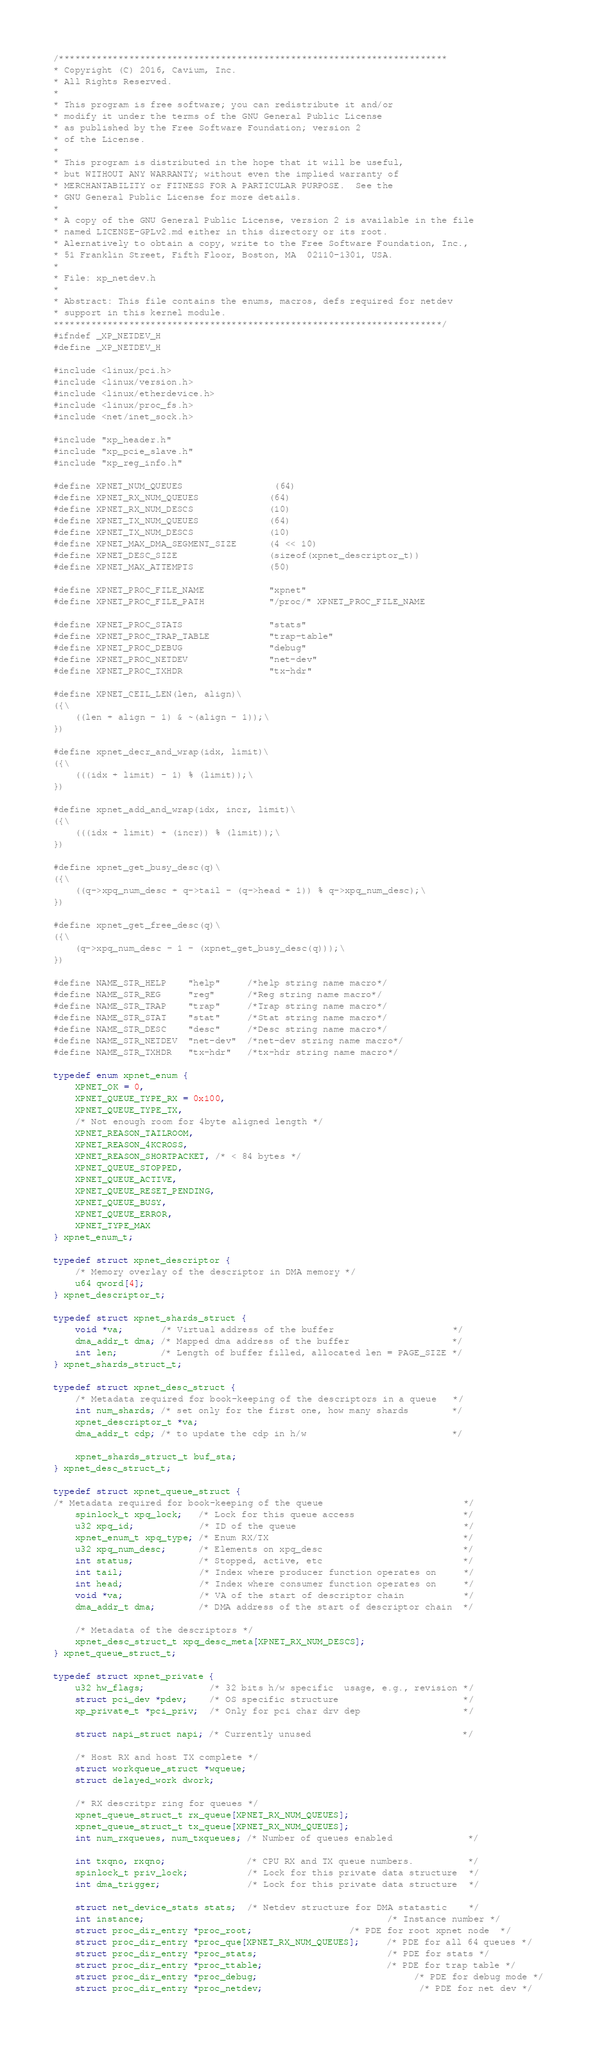Convert code to text. <code><loc_0><loc_0><loc_500><loc_500><_C_>/************************************************************************
* Copyright (C) 2016, Cavium, Inc.
* All Rights Reserved.
*
* This program is free software; you can redistribute it and/or
* modify it under the terms of the GNU General Public License
* as published by the Free Software Foundation; version 2
* of the License.
* 
* This program is distributed in the hope that it will be useful,
* but WITHOUT ANY WARRANTY; without even the implied warranty of
* MERCHANTABILITY or FITNESS FOR A PARTICULAR PURPOSE.  See the
* GNU General Public License for more details.
* 
* A copy of the GNU General Public License, version 2 is available in the file 
* named LICENSE-GPLv2.md either in this directory or its root. 
* Alernatively to obtain a copy, write to the Free Software Foundation, Inc., 
* 51 Franklin Street, Fifth Floor, Boston, MA  02110-1301, USA.
*
* File: xp_netdev.h
* 
* Abstract: This file contains the enums, macros, defs required for netdev 
* support in this kernel module.
************************************************************************/
#ifndef _XP_NETDEV_H
#define _XP_NETDEV_H

#include <linux/pci.h>
#include <linux/version.h>
#include <linux/etherdevice.h>
#include <linux/proc_fs.h>
#include <net/inet_sock.h>

#include "xp_header.h"
#include "xp_pcie_slave.h"
#include "xp_reg_info.h"

#define XPNET_NUM_QUEUES             	(64)
#define XPNET_RX_NUM_QUEUES             (64)
#define XPNET_RX_NUM_DESCS              (10)
#define XPNET_TX_NUM_QUEUES             (64)
#define XPNET_TX_NUM_DESCS              (10)
#define XPNET_MAX_DMA_SEGMENT_SIZE      (4 << 10)
#define XPNET_DESC_SIZE                 (sizeof(xpnet_descriptor_t))
#define XPNET_MAX_ATTEMPTS              (50)

#define XPNET_PROC_FILE_NAME            "xpnet"
#define XPNET_PROC_FILE_PATH            "/proc/" XPNET_PROC_FILE_NAME

#define XPNET_PROC_STATS                "stats"
#define XPNET_PROC_TRAP_TABLE           "trap-table"
#define XPNET_PROC_DEBUG                "debug"
#define XPNET_PROC_NETDEV               "net-dev"
#define XPNET_PROC_TXHDR                "tx-hdr"

#define XPNET_CEIL_LEN(len, align)\
({\
    ((len + align - 1) & ~(align - 1));\
})

#define xpnet_decr_and_wrap(idx, limit)\
({\
    (((idx + limit) - 1) % (limit));\
})

#define xpnet_add_and_wrap(idx, incr, limit)\
({\
    (((idx + limit) + (incr)) % (limit));\
})

#define xpnet_get_busy_desc(q)\
({\
    ((q->xpq_num_desc + q->tail - (q->head + 1)) % q->xpq_num_desc);\
})

#define xpnet_get_free_desc(q)\
({\
    (q->xpq_num_desc - 1 - (xpnet_get_busy_desc(q)));\
})

#define NAME_STR_HELP    "help"     /*help string name macro*/
#define NAME_STR_REG     "reg"      /*Reg string name macro*/
#define NAME_STR_TRAP    "trap"     /*Trap string name macro*/
#define NAME_STR_STAT    "stat"     /*Stat string name macro*/
#define NAME_STR_DESC    "desc"     /*Desc string name macro*/
#define NAME_STR_NETDEV  "net-dev"  /*net-dev string name macro*/
#define NAME_STR_TXHDR   "tx-hdr"   /*tx-hdr string name macro*/

typedef enum xpnet_enum {
    XPNET_OK = 0,
    XPNET_QUEUE_TYPE_RX = 0x100,
    XPNET_QUEUE_TYPE_TX,
    /* Not enough room for 4byte aligned length */
    XPNET_REASON_TAILROOM,
    XPNET_REASON_4KCROSS,
    XPNET_REASON_SHORTPACKET, /* < 84 bytes */
    XPNET_QUEUE_STOPPED,
    XPNET_QUEUE_ACTIVE,
    XPNET_QUEUE_RESET_PENDING,
    XPNET_QUEUE_BUSY,
    XPNET_QUEUE_ERROR,
    XPNET_TYPE_MAX
} xpnet_enum_t;

typedef struct xpnet_descriptor {
    /* Memory overlay of the descriptor in DMA memory */
    u64 qword[4];
} xpnet_descriptor_t;

typedef struct xpnet_shards_struct {
    void *va;       /* Virtual address of the buffer                      */
    dma_addr_t dma; /* Mapped dma address of the buffer                   */
    int len;        /* Length of buffer filled, allocated len = PAGE_SIZE */
} xpnet_shards_struct_t;

typedef struct xpnet_desc_struct {
    /* Metadata required for book-keeping of the descriptors in a queue   */
    int num_shards; /* set only for the first one, how many shards        */
    xpnet_descriptor_t *va;
    dma_addr_t cdp; /* to update the cdp in h/w                           */

    xpnet_shards_struct_t buf_sta;
} xpnet_desc_struct_t;

typedef struct xpnet_queue_struct {
/* Metadata required for book-keeping of the queue                          */
    spinlock_t xpq_lock;   /* Lock for this queue access                    */
    u32 xpq_id;            /* ID of the queue                               */
    xpnet_enum_t xpq_type; /* Enum RX/TX                                    */
    u32 xpq_num_desc;      /* Elements on xpq_desc                          */
    int status;            /* Stopped, active, etc                          */
    int tail;              /* Index where producer function operates on     */
    int head;              /* Index where consumer function operates on     */
    void *va;              /* VA of the start of descriptor chain           */
    dma_addr_t dma;        /* DMA address of the start of descriptor chain  */

    /* Metadata of the descriptors */
    xpnet_desc_struct_t xpq_desc_meta[XPNET_RX_NUM_DESCS];
} xpnet_queue_struct_t;

typedef struct xpnet_private {
    u32 hw_flags;            /* 32 bits h/w specific  usage, e.g., revision */
    struct pci_dev *pdev;    /* OS specific structure                       */
    xp_private_t *pci_priv;  /* Only for pci char drv dep                   */

    struct napi_struct napi; /* Currently unused                            */

    /* Host RX and host TX complete */
    struct workqueue_struct *wqueue;
    struct delayed_work dwork;

    /* RX descritpr ring for queues */
    xpnet_queue_struct_t rx_queue[XPNET_RX_NUM_QUEUES];
    xpnet_queue_struct_t tx_queue[XPNET_RX_NUM_QUEUES];
    int num_rxqueues, num_txqueues; /* Number of queues enabled              */

    int txqno, rxqno;               /* CPU RX and TX queue numbers.          */
    spinlock_t priv_lock;           /* Lock for this private data structure  */
    int dma_trigger;                /* Lock for this private data structure  */

    struct net_device_stats stats;  /* Netdev structure for DMA statastic    */
    int instance;                                             /* Instance number */
    struct proc_dir_entry *proc_root;     		      /* PDE for root xpnet node  */
    struct proc_dir_entry *proc_que[XPNET_RX_NUM_QUEUES];     /* PDE for all 64 queues */
    struct proc_dir_entry *proc_stats;                        /* PDE for stats */
    struct proc_dir_entry *proc_ttable;                       /* PDE for trap table */
    struct proc_dir_entry *proc_debug;                             /* PDE for debug mode */
    struct proc_dir_entry *proc_netdev;                             /* PDE for net dev */</code> 